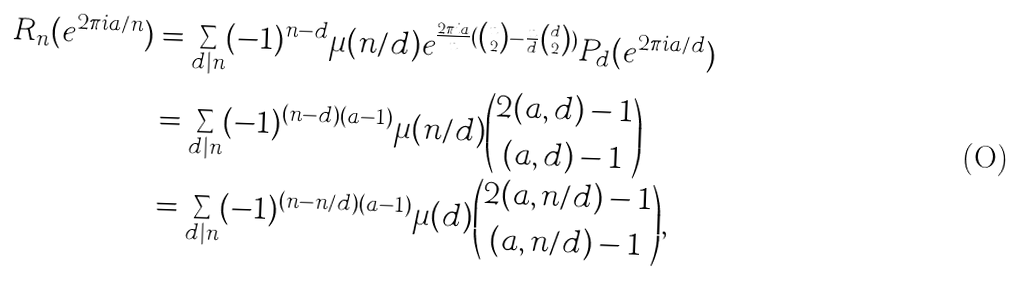<formula> <loc_0><loc_0><loc_500><loc_500>R _ { n } ( e ^ { 2 \pi i a / n } ) & = \sum _ { d | n } ( - 1 ) ^ { n - d } \mu ( n / d ) e ^ { \frac { 2 \pi i a } { n } ( \binom { n } { 2 } - \frac { n } { d } \binom { d } { 2 } ) } P _ { d } ( e ^ { 2 \pi i a / d } ) \\ & = \sum _ { d | n } ( - 1 ) ^ { ( n - d ) ( a - 1 ) } \mu ( n / d ) \binom { 2 ( a , d ) - 1 } { ( a , d ) - 1 } \\ & = \sum _ { d | n } ( - 1 ) ^ { ( n - n / d ) ( a - 1 ) } \mu ( d ) \binom { 2 ( a , n / d ) - 1 } { ( a , n / d ) - 1 } ,</formula> 